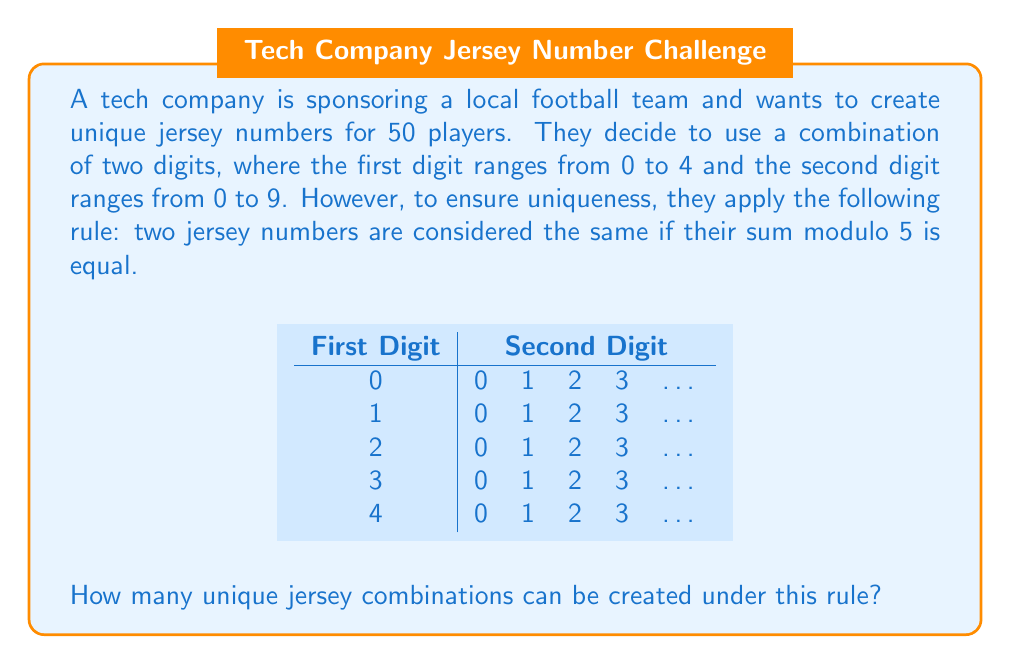What is the answer to this math problem? Let's approach this step-by-step:

1) First, we need to understand what the question is asking. We're looking for unique combinations where two jerseys are considered the same if their sum modulo 5 is equal.

2) The total number of possible combinations without the modulo rule would be 5 * 10 = 50, as we have 5 choices for the first digit and 10 for the second.

3) Now, let's consider the modulo rule. We need to group the numbers based on their sum modulo 5:

   Group 0: 00, 05, 10, 15, 20, 25, 30, 35, 40, 45
   Group 1: 01, 06, 11, 16, 21, 26, 31, 36, 41, 46
   Group 2: 02, 07, 12, 17, 22, 27, 32, 37, 42, 47
   Group 3: 03, 08, 13, 18, 23, 28, 33, 38, 43, 48
   Group 4: 04, 09, 14, 19, 24, 29, 34, 39, 44, 49

4) Each group represents one unique combination under the modulo rule.

5) Therefore, the number of unique combinations is equal to the number of groups, which is 5.

This can also be understood through the lens of Ring theory. The set of jersey numbers forms a ring under addition modulo 5. The unique combinations we're looking for are actually the cosets of this ring with respect to the subgroup generated by 5.
Answer: 5 